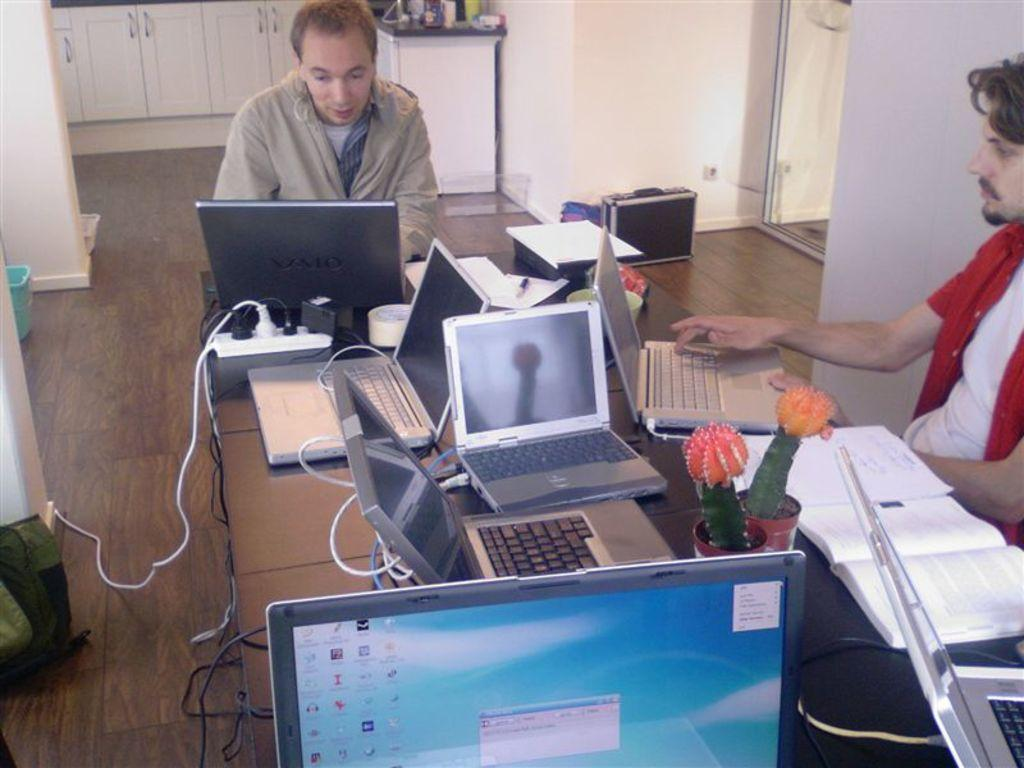<image>
Present a compact description of the photo's key features. A man types on a Valo laptop next to another guy. 